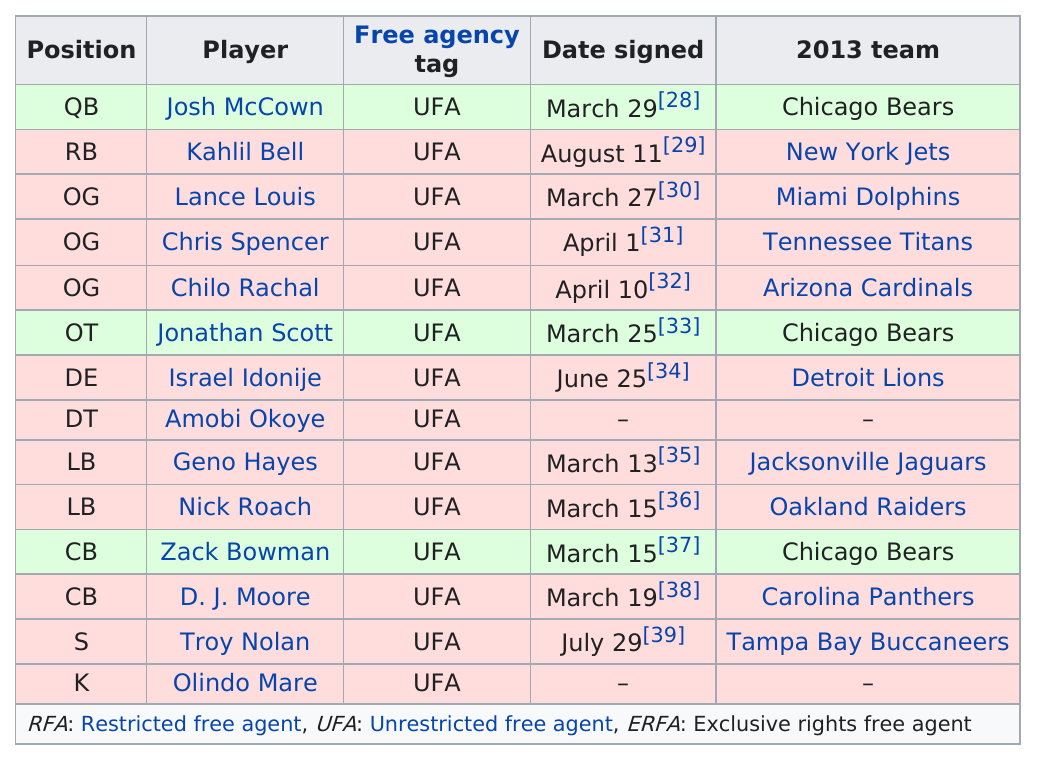Specify some key components in this picture. Chris Spencer signed the same date as April Fools Day. Troy Nolan's last name is also a first name, which begins with the letter 'n'. This season, our team acquired a total of 14 free agents, showcasing our commitment to strengthening our roster through smart and strategic signings. According to the chart provided, the most frequently played position is OG. Nick Roach was signed on the same day as another player, Zack Bowman. 